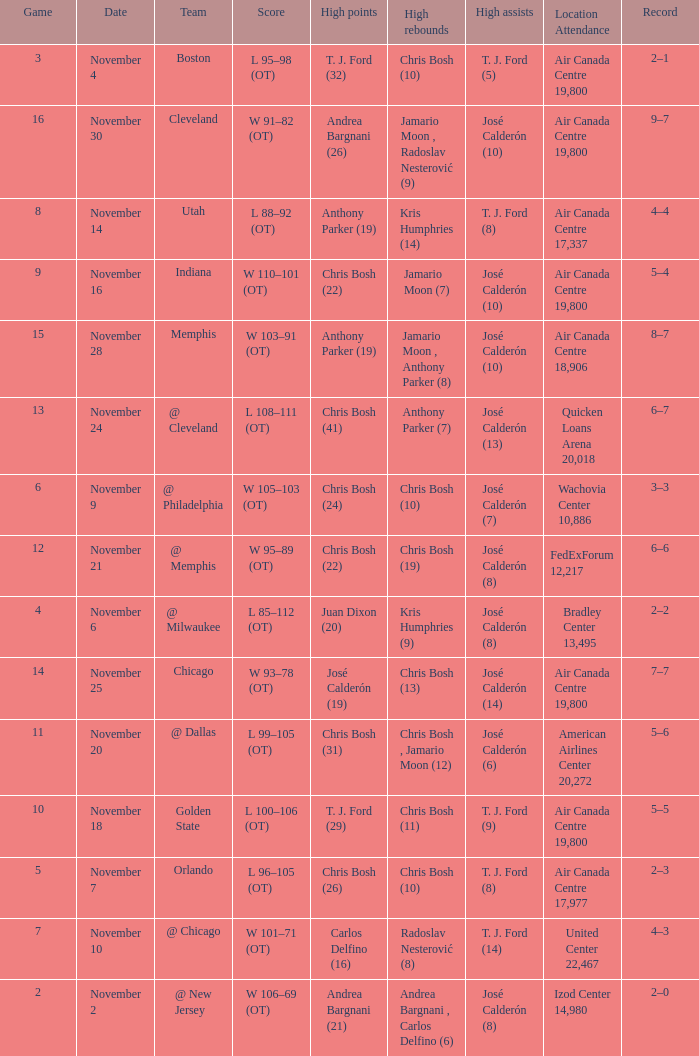What is the score when the team is @ cleveland? L 108–111 (OT). 